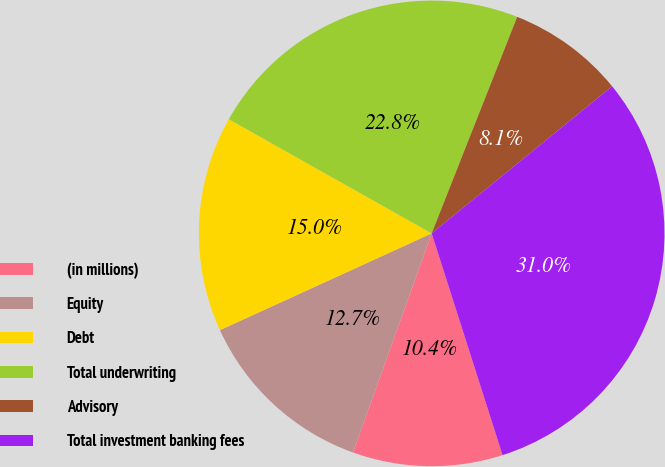Convert chart to OTSL. <chart><loc_0><loc_0><loc_500><loc_500><pie_chart><fcel>(in millions)<fcel>Equity<fcel>Debt<fcel>Total underwriting<fcel>Advisory<fcel>Total investment banking fees<nl><fcel>10.41%<fcel>12.69%<fcel>14.98%<fcel>22.83%<fcel>8.13%<fcel>30.96%<nl></chart> 